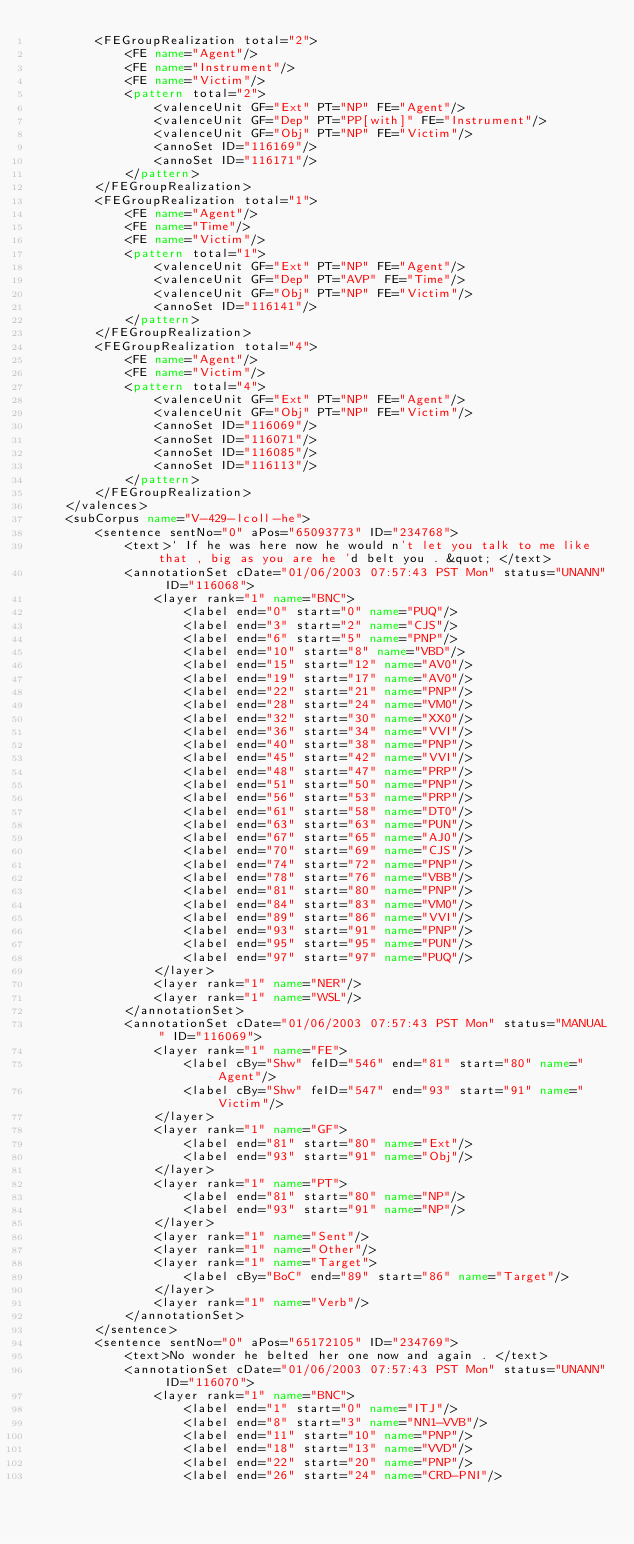<code> <loc_0><loc_0><loc_500><loc_500><_XML_>        <FEGroupRealization total="2">
            <FE name="Agent"/>
            <FE name="Instrument"/>
            <FE name="Victim"/>
            <pattern total="2">
                <valenceUnit GF="Ext" PT="NP" FE="Agent"/>
                <valenceUnit GF="Dep" PT="PP[with]" FE="Instrument"/>
                <valenceUnit GF="Obj" PT="NP" FE="Victim"/>
                <annoSet ID="116169"/>
                <annoSet ID="116171"/>
            </pattern>
        </FEGroupRealization>
        <FEGroupRealization total="1">
            <FE name="Agent"/>
            <FE name="Time"/>
            <FE name="Victim"/>
            <pattern total="1">
                <valenceUnit GF="Ext" PT="NP" FE="Agent"/>
                <valenceUnit GF="Dep" PT="AVP" FE="Time"/>
                <valenceUnit GF="Obj" PT="NP" FE="Victim"/>
                <annoSet ID="116141"/>
            </pattern>
        </FEGroupRealization>
        <FEGroupRealization total="4">
            <FE name="Agent"/>
            <FE name="Victim"/>
            <pattern total="4">
                <valenceUnit GF="Ext" PT="NP" FE="Agent"/>
                <valenceUnit GF="Obj" PT="NP" FE="Victim"/>
                <annoSet ID="116069"/>
                <annoSet ID="116071"/>
                <annoSet ID="116085"/>
                <annoSet ID="116113"/>
            </pattern>
        </FEGroupRealization>
    </valences>
    <subCorpus name="V-429-lcoll-he">
        <sentence sentNo="0" aPos="65093773" ID="234768">
            <text>` If he was here now he would n't let you talk to me like that , big as you are he 'd belt you . &quot; </text>
            <annotationSet cDate="01/06/2003 07:57:43 PST Mon" status="UNANN" ID="116068">
                <layer rank="1" name="BNC">
                    <label end="0" start="0" name="PUQ"/>
                    <label end="3" start="2" name="CJS"/>
                    <label end="6" start="5" name="PNP"/>
                    <label end="10" start="8" name="VBD"/>
                    <label end="15" start="12" name="AV0"/>
                    <label end="19" start="17" name="AV0"/>
                    <label end="22" start="21" name="PNP"/>
                    <label end="28" start="24" name="VM0"/>
                    <label end="32" start="30" name="XX0"/>
                    <label end="36" start="34" name="VVI"/>
                    <label end="40" start="38" name="PNP"/>
                    <label end="45" start="42" name="VVI"/>
                    <label end="48" start="47" name="PRP"/>
                    <label end="51" start="50" name="PNP"/>
                    <label end="56" start="53" name="PRP"/>
                    <label end="61" start="58" name="DT0"/>
                    <label end="63" start="63" name="PUN"/>
                    <label end="67" start="65" name="AJ0"/>
                    <label end="70" start="69" name="CJS"/>
                    <label end="74" start="72" name="PNP"/>
                    <label end="78" start="76" name="VBB"/>
                    <label end="81" start="80" name="PNP"/>
                    <label end="84" start="83" name="VM0"/>
                    <label end="89" start="86" name="VVI"/>
                    <label end="93" start="91" name="PNP"/>
                    <label end="95" start="95" name="PUN"/>
                    <label end="97" start="97" name="PUQ"/>
                </layer>
                <layer rank="1" name="NER"/>
                <layer rank="1" name="WSL"/>
            </annotationSet>
            <annotationSet cDate="01/06/2003 07:57:43 PST Mon" status="MANUAL" ID="116069">
                <layer rank="1" name="FE">
                    <label cBy="Shw" feID="546" end="81" start="80" name="Agent"/>
                    <label cBy="Shw" feID="547" end="93" start="91" name="Victim"/>
                </layer>
                <layer rank="1" name="GF">
                    <label end="81" start="80" name="Ext"/>
                    <label end="93" start="91" name="Obj"/>
                </layer>
                <layer rank="1" name="PT">
                    <label end="81" start="80" name="NP"/>
                    <label end="93" start="91" name="NP"/>
                </layer>
                <layer rank="1" name="Sent"/>
                <layer rank="1" name="Other"/>
                <layer rank="1" name="Target">
                    <label cBy="BoC" end="89" start="86" name="Target"/>
                </layer>
                <layer rank="1" name="Verb"/>
            </annotationSet>
        </sentence>
        <sentence sentNo="0" aPos="65172105" ID="234769">
            <text>No wonder he belted her one now and again . </text>
            <annotationSet cDate="01/06/2003 07:57:43 PST Mon" status="UNANN" ID="116070">
                <layer rank="1" name="BNC">
                    <label end="1" start="0" name="ITJ"/>
                    <label end="8" start="3" name="NN1-VVB"/>
                    <label end="11" start="10" name="PNP"/>
                    <label end="18" start="13" name="VVD"/>
                    <label end="22" start="20" name="PNP"/>
                    <label end="26" start="24" name="CRD-PNI"/></code> 